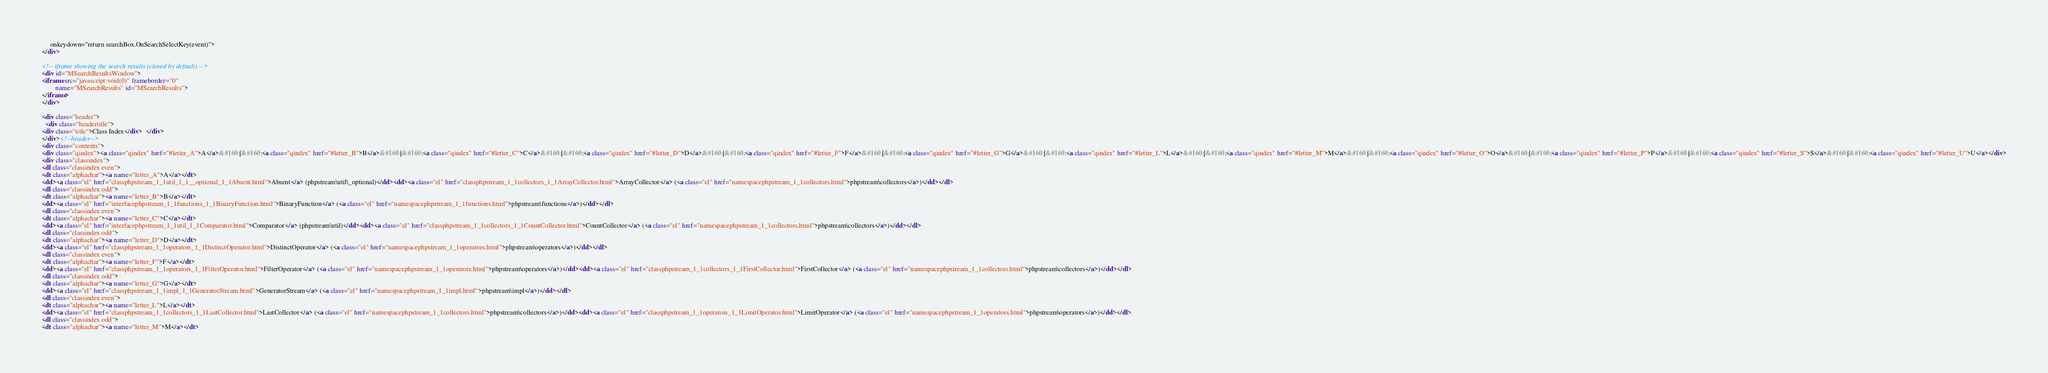<code> <loc_0><loc_0><loc_500><loc_500><_HTML_>     onkeydown="return searchBox.OnSearchSelectKey(event)">
</div>

<!-- iframe showing the search results (closed by default) -->
<div id="MSearchResultsWindow">
<iframe src="javascript:void(0)" frameborder="0" 
        name="MSearchResults" id="MSearchResults">
</iframe>
</div>

<div class="header">
  <div class="headertitle">
<div class="title">Class Index</div>  </div>
</div><!--header-->
<div class="contents">
<div class="qindex"><a class="qindex" href="#letter_A">A</a>&#160;|&#160;<a class="qindex" href="#letter_B">B</a>&#160;|&#160;<a class="qindex" href="#letter_C">C</a>&#160;|&#160;<a class="qindex" href="#letter_D">D</a>&#160;|&#160;<a class="qindex" href="#letter_F">F</a>&#160;|&#160;<a class="qindex" href="#letter_G">G</a>&#160;|&#160;<a class="qindex" href="#letter_L">L</a>&#160;|&#160;<a class="qindex" href="#letter_M">M</a>&#160;|&#160;<a class="qindex" href="#letter_O">O</a>&#160;|&#160;<a class="qindex" href="#letter_P">P</a>&#160;|&#160;<a class="qindex" href="#letter_S">S</a>&#160;|&#160;<a class="qindex" href="#letter_U">U</a></div>
<div class="classindex">
<dl class="classindex even">
<dt class="alphachar"><a name="letter_A">A</a></dt>
<dd><a class="el" href="classphpstream_1_1util_1_1__optional_1_1Absent.html">Absent</a> (phpstream\util\_optional)</dd><dd><a class="el" href="classphpstream_1_1collectors_1_1ArrayCollector.html">ArrayCollector</a> (<a class="el" href="namespacephpstream_1_1collectors.html">phpstream\collectors</a>)</dd></dl>
<dl class="classindex odd">
<dt class="alphachar"><a name="letter_B">B</a></dt>
<dd><a class="el" href="interfacephpstream_1_1functions_1_1BinaryFunction.html">BinaryFunction</a> (<a class="el" href="namespacephpstream_1_1functions.html">phpstream\functions</a>)</dd></dl>
<dl class="classindex even">
<dt class="alphachar"><a name="letter_C">C</a></dt>
<dd><a class="el" href="interfacephpstream_1_1util_1_1Comparator.html">Comparator</a> (phpstream\util)</dd><dd><a class="el" href="classphpstream_1_1collectors_1_1CountCollector.html">CountCollector</a> (<a class="el" href="namespacephpstream_1_1collectors.html">phpstream\collectors</a>)</dd></dl>
<dl class="classindex odd">
<dt class="alphachar"><a name="letter_D">D</a></dt>
<dd><a class="el" href="classphpstream_1_1operators_1_1DistinctOperator.html">DistinctOperator</a> (<a class="el" href="namespacephpstream_1_1operators.html">phpstream\operators</a>)</dd></dl>
<dl class="classindex even">
<dt class="alphachar"><a name="letter_F">F</a></dt>
<dd><a class="el" href="classphpstream_1_1operators_1_1FilterOperator.html">FilterOperator</a> (<a class="el" href="namespacephpstream_1_1operators.html">phpstream\operators</a>)</dd><dd><a class="el" href="classphpstream_1_1collectors_1_1FirstCollector.html">FirstCollector</a> (<a class="el" href="namespacephpstream_1_1collectors.html">phpstream\collectors</a>)</dd></dl>
<dl class="classindex odd">
<dt class="alphachar"><a name="letter_G">G</a></dt>
<dd><a class="el" href="classphpstream_1_1impl_1_1GeneratorStream.html">GeneratorStream</a> (<a class="el" href="namespacephpstream_1_1impl.html">phpstream\impl</a>)</dd></dl>
<dl class="classindex even">
<dt class="alphachar"><a name="letter_L">L</a></dt>
<dd><a class="el" href="classphpstream_1_1collectors_1_1LastCollector.html">LastCollector</a> (<a class="el" href="namespacephpstream_1_1collectors.html">phpstream\collectors</a>)</dd><dd><a class="el" href="classphpstream_1_1operators_1_1LimitOperator.html">LimitOperator</a> (<a class="el" href="namespacephpstream_1_1operators.html">phpstream\operators</a>)</dd></dl>
<dl class="classindex odd">
<dt class="alphachar"><a name="letter_M">M</a></dt></code> 